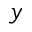<formula> <loc_0><loc_0><loc_500><loc_500>y</formula> 